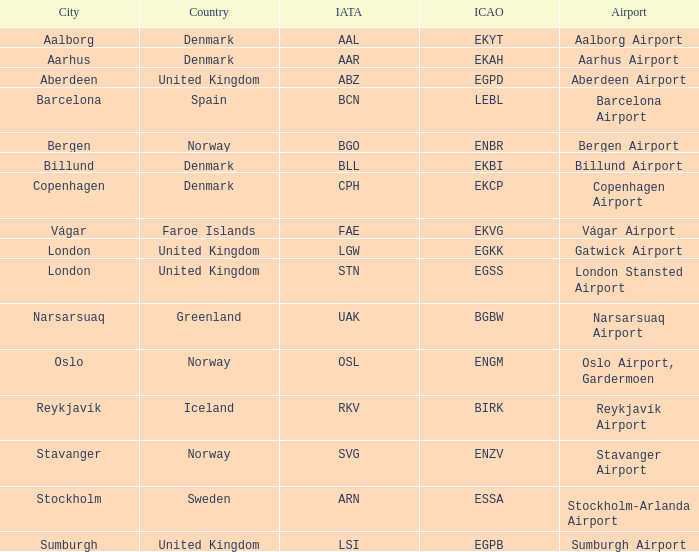What airport has an ICAP of BGBW? Narsarsuaq Airport. Could you parse the entire table as a dict? {'header': ['City', 'Country', 'IATA', 'ICAO', 'Airport'], 'rows': [['Aalborg', 'Denmark', 'AAL', 'EKYT', 'Aalborg Airport'], ['Aarhus', 'Denmark', 'AAR', 'EKAH', 'Aarhus Airport'], ['Aberdeen', 'United Kingdom', 'ABZ', 'EGPD', 'Aberdeen Airport'], ['Barcelona', 'Spain', 'BCN', 'LEBL', 'Barcelona Airport'], ['Bergen', 'Norway', 'BGO', 'ENBR', 'Bergen Airport'], ['Billund', 'Denmark', 'BLL', 'EKBI', 'Billund Airport'], ['Copenhagen', 'Denmark', 'CPH', 'EKCP', 'Copenhagen Airport'], ['Vágar', 'Faroe Islands', 'FAE', 'EKVG', 'Vágar Airport'], ['London', 'United Kingdom', 'LGW', 'EGKK', 'Gatwick Airport'], ['London', 'United Kingdom', 'STN', 'EGSS', 'London Stansted Airport'], ['Narsarsuaq', 'Greenland', 'UAK', 'BGBW', 'Narsarsuaq Airport'], ['Oslo', 'Norway', 'OSL', 'ENGM', 'Oslo Airport, Gardermoen'], ['Reykjavík', 'Iceland', 'RKV', 'BIRK', 'Reykjavík Airport'], ['Stavanger', 'Norway', 'SVG', 'ENZV', 'Stavanger Airport'], ['Stockholm', 'Sweden', 'ARN', 'ESSA', 'Stockholm-Arlanda Airport'], ['Sumburgh', 'United Kingdom', 'LSI', 'EGPB', 'Sumburgh Airport']]} 